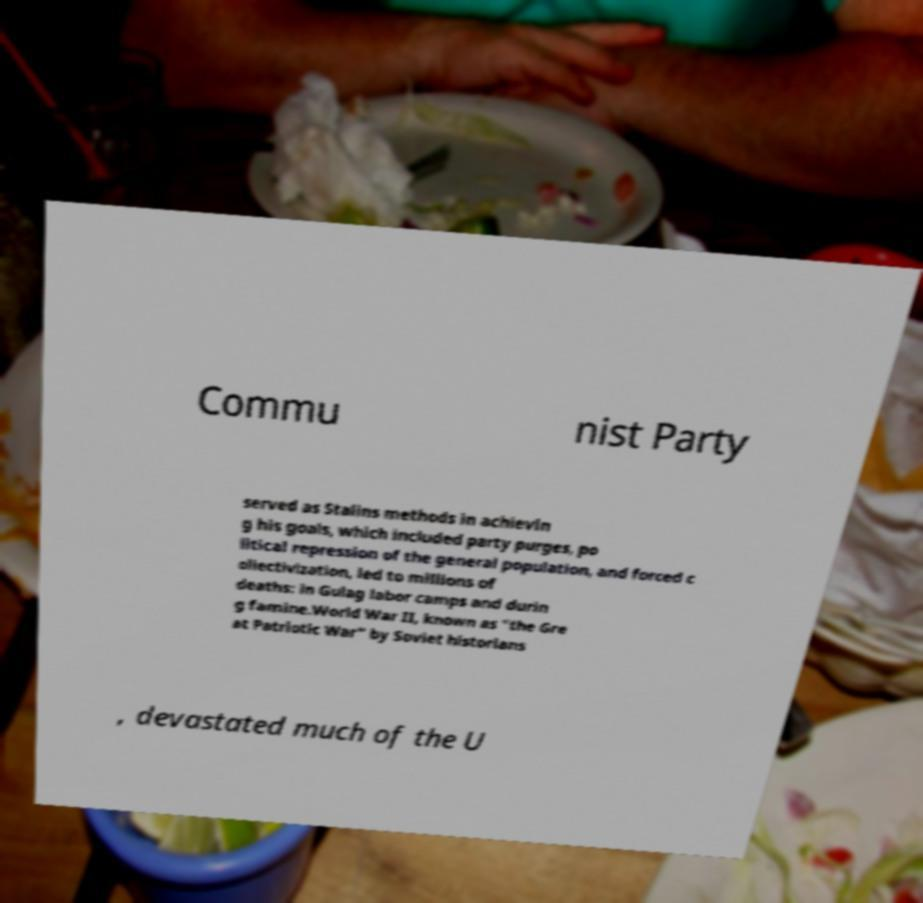What messages or text are displayed in this image? I need them in a readable, typed format. Commu nist Party served as Stalins methods in achievin g his goals, which included party purges, po litical repression of the general population, and forced c ollectivization, led to millions of deaths: in Gulag labor camps and durin g famine.World War II, known as "the Gre at Patriotic War" by Soviet historians , devastated much of the U 